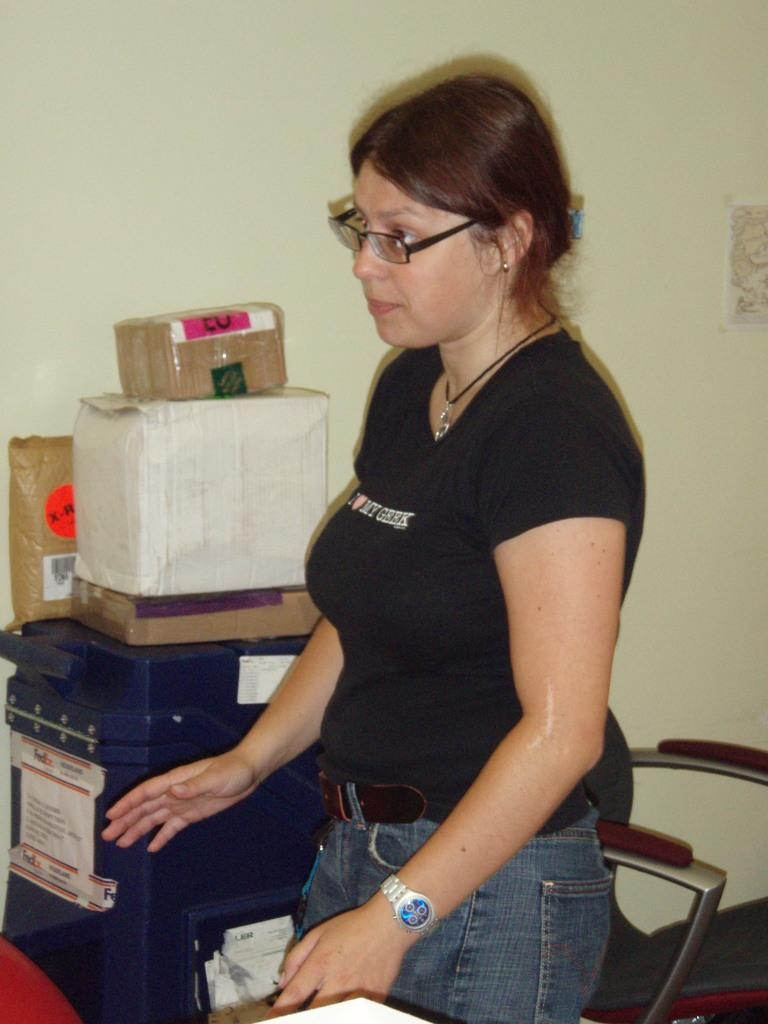Who is present in the image? There is a woman in the image. What is the woman sitting on in the image? There is a chair in the image. What else can be seen in the image besides the woman and the chair? There are boxes and other objects in the image. What is visible in the background of the image? There is a wall in the background of the image. Can you describe anything on the wall? There is a sticker on the wall. What type of pen is the woman holding in the image? There is no pen present in the image. Can you tell me how many friends are visible in the image? There are no friends visible in the image; only a woman is present. 